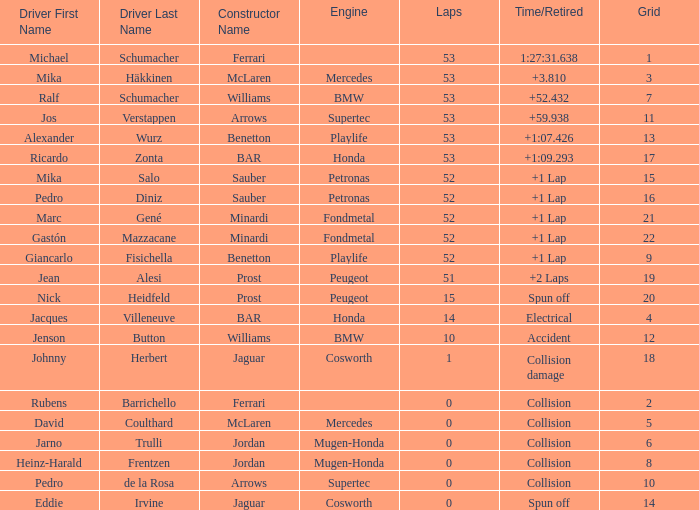How many loops did ricardo zonta achieve? 53.0. 